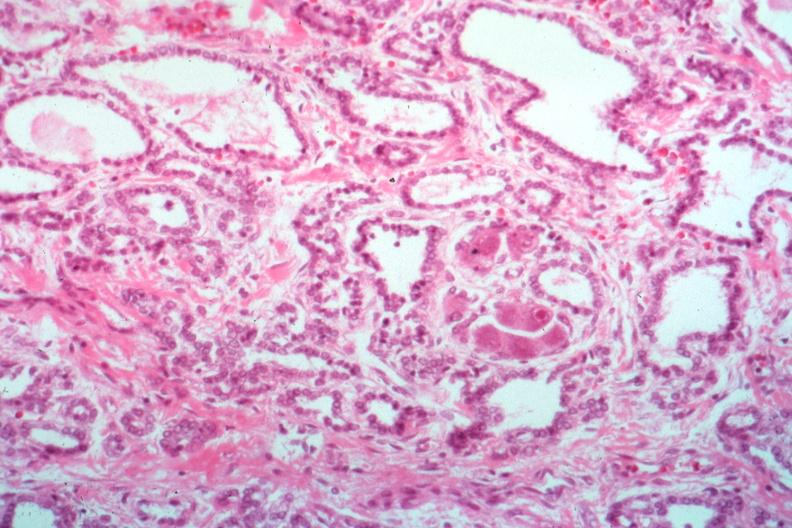s cytomegalovirus present?
Answer the question using a single word or phrase. Yes 